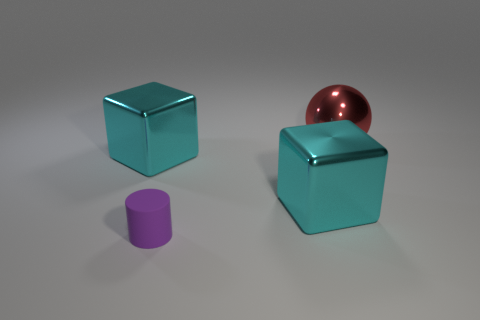Are there any other things that have the same size as the cylinder?
Provide a succinct answer. No. How many objects are metallic cubes that are to the left of the purple matte cylinder or tiny purple matte cylinders?
Keep it short and to the point. 2. Are there an equal number of objects that are on the left side of the cylinder and tiny objects?
Your response must be concise. Yes. What number of red things have the same size as the purple cylinder?
Your answer should be compact. 0. What number of big cyan metallic objects are right of the small cylinder?
Give a very brief answer. 1. There is a large cyan object that is left of the large block that is to the right of the small rubber cylinder; what is its material?
Your answer should be compact. Metal. Are there any other things that are the same color as the matte object?
Give a very brief answer. No. What color is the big shiny block that is on the right side of the small purple cylinder?
Provide a short and direct response. Cyan. There is a metal block that is to the right of the large block that is to the left of the purple matte thing; are there any large red balls that are to the right of it?
Your answer should be compact. Yes. Is the number of cyan objects that are behind the rubber object greater than the number of large red cubes?
Your answer should be very brief. Yes. 